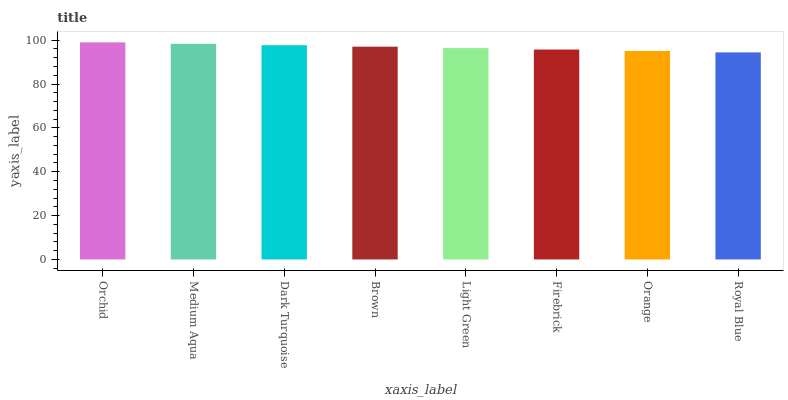Is Royal Blue the minimum?
Answer yes or no. Yes. Is Orchid the maximum?
Answer yes or no. Yes. Is Medium Aqua the minimum?
Answer yes or no. No. Is Medium Aqua the maximum?
Answer yes or no. No. Is Orchid greater than Medium Aqua?
Answer yes or no. Yes. Is Medium Aqua less than Orchid?
Answer yes or no. Yes. Is Medium Aqua greater than Orchid?
Answer yes or no. No. Is Orchid less than Medium Aqua?
Answer yes or no. No. Is Brown the high median?
Answer yes or no. Yes. Is Light Green the low median?
Answer yes or no. Yes. Is Light Green the high median?
Answer yes or no. No. Is Orchid the low median?
Answer yes or no. No. 